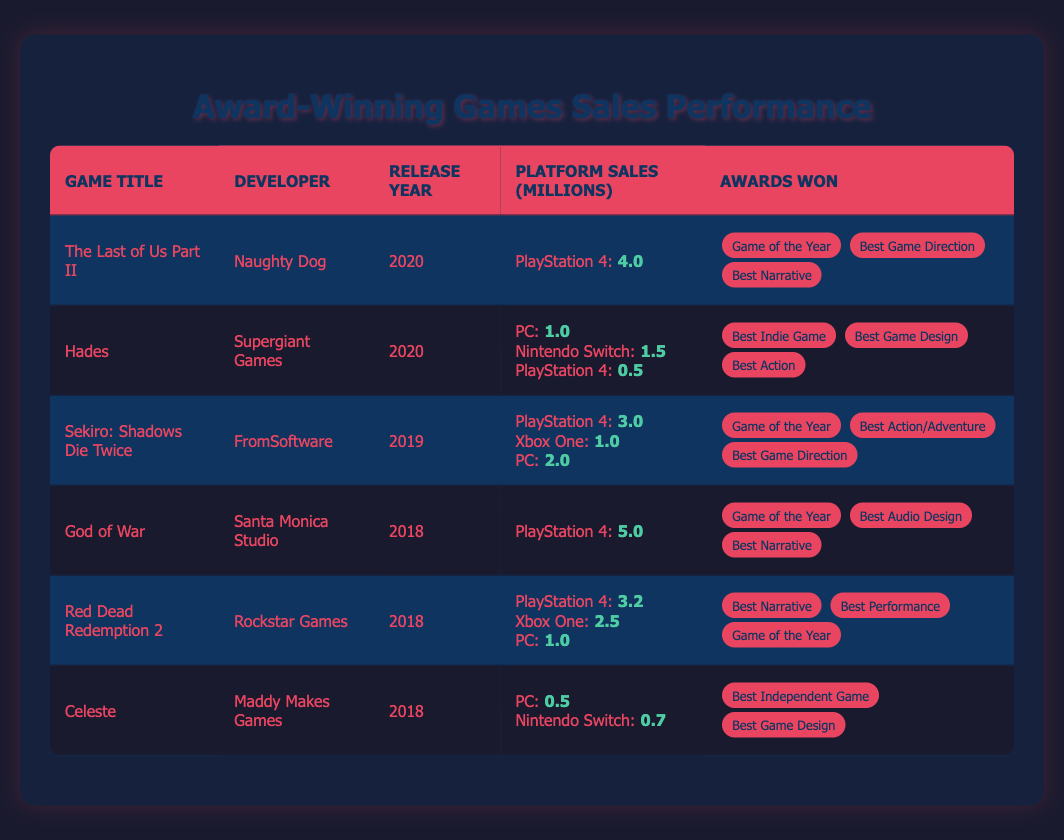What game released in 2020 won the most awards? The table lists "The Last of Us Part II" and "Hades" as games released in 2020, with 3 awards and 3 awards respectively. They both won the same number of awards, but since both have the same count, they are equally matched in this regard.
Answer: Both "The Last of Us Part II" and "Hades" won 3 awards Which game had the highest sales on PlayStation 4? By examining the sales figures in the table, "God of War" has the highest sales on PlayStation 4 listed as 5.0 million, higher than "The Last of Us Part II" at 4.0 million.
Answer: God of War with 5.0 million sales What is the total sales for "Red Dead Redemption 2"? The sales figures on different platforms for "Red Dead Redemption 2" are 3.2 million (PlayStation 4) + 2.5 million (Xbox One) + 1.0 million (PC) = 6.7 million total sales.
Answer: 6.7 million Did "Celeste" win a Game of the Year award? The table notes that "Celeste" won "Best Independent Game" and "Best Game Design," but does not indicate it won "Game of the Year," so it did not win that award.
Answer: No How many total platforms did "Hades" release on? Looking at the table, "Hades" is listed as releasing on three platforms: PC, Nintendo Switch, and PlayStation 4.
Answer: 3 platforms What is the average sales for games released in 2018? The total sales for games released in 2018 are "God of War" (5.0) + "Red Dead Redemption 2" (3.2 + 2.5 + 1.0 for all platforms) + "Celeste" (0.5 + 0.7). The total sum is 5.0 + (3.2 + 2.5 + 1.0) + (0.5 + 0.7) = 5.0 + 6.7 + 1.2 = 12.9 million, with three games. The average is 12.9 / 3 = 4.3 million.
Answer: 4.3 million Which game developer has the most varied platform availability based on the table? "Hades" developed by Supergiant Games appears on three platforms: PC, Nintendo Switch, and PlayStation 4. "Red Dead Redemption 2" is next with three platforms as well, but "Hades" has a longer range of availability overall.
Answer: Supergiant Games with "Hades" Which award did "Sekiro: Shadows Die Twice" win that is also shared with "The Last of Us Part II"? Both "Sekiro: Shadows Die Twice" and "The Last of Us Part II" won the "Game of the Year" award.
Answer: Game of the Year What percent of total sales (across all platforms) did "Hades" achieve? The total sales for "Hades" is 1.0 (PC) + 1.5 (Nintendo Switch) + 0.5 (PlayStation 4) = 3.0 million. The total sales from all games are 4.0 + 3.0 + 6.7 + 5.0 + 6.7 + 1.2. Adding these totals: 4.0 + 3.0 + 6.7 + 5.0 + 6.7 + 1.2 = 26.8 million. To find the percentage: (3.0 / 26.8) * 100 = 11.19%.
Answer: 11.19% Among the games, which one has the least sales overall? "Celeste" has the lowest sales with 0.5 million (PC) and 0.7 million (Switch), totaling only 1.2 million across its platforms.
Answer: Celeste with 1.2 million 